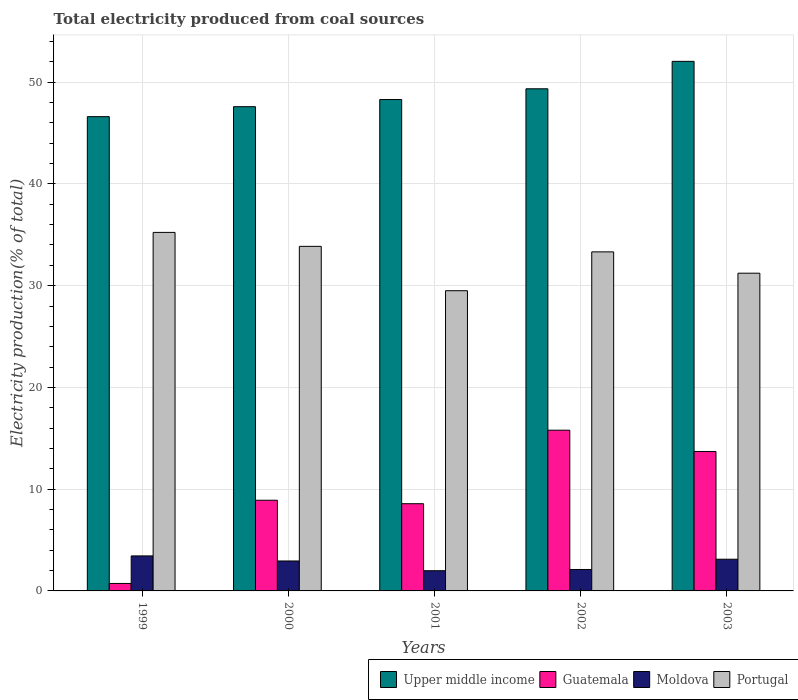How many groups of bars are there?
Your answer should be very brief. 5. Are the number of bars per tick equal to the number of legend labels?
Your answer should be very brief. Yes. Are the number of bars on each tick of the X-axis equal?
Your response must be concise. Yes. How many bars are there on the 3rd tick from the left?
Offer a terse response. 4. How many bars are there on the 3rd tick from the right?
Offer a very short reply. 4. What is the label of the 4th group of bars from the left?
Your response must be concise. 2002. In how many cases, is the number of bars for a given year not equal to the number of legend labels?
Provide a succinct answer. 0. What is the total electricity produced in Portugal in 2002?
Your answer should be compact. 33.32. Across all years, what is the maximum total electricity produced in Upper middle income?
Your answer should be compact. 52.05. Across all years, what is the minimum total electricity produced in Portugal?
Your answer should be very brief. 29.51. In which year was the total electricity produced in Portugal maximum?
Ensure brevity in your answer.  1999. What is the total total electricity produced in Moldova in the graph?
Make the answer very short. 13.59. What is the difference between the total electricity produced in Moldova in 2001 and that in 2002?
Offer a terse response. -0.12. What is the difference between the total electricity produced in Portugal in 2000 and the total electricity produced in Moldova in 1999?
Give a very brief answer. 30.42. What is the average total electricity produced in Portugal per year?
Your answer should be compact. 32.63. In the year 2000, what is the difference between the total electricity produced in Upper middle income and total electricity produced in Portugal?
Offer a very short reply. 13.73. In how many years, is the total electricity produced in Upper middle income greater than 14 %?
Your answer should be very brief. 5. What is the ratio of the total electricity produced in Guatemala in 2000 to that in 2001?
Make the answer very short. 1.04. What is the difference between the highest and the second highest total electricity produced in Moldova?
Provide a succinct answer. 0.33. What is the difference between the highest and the lowest total electricity produced in Guatemala?
Your answer should be compact. 15.06. Is the sum of the total electricity produced in Upper middle income in 2001 and 2003 greater than the maximum total electricity produced in Guatemala across all years?
Offer a very short reply. Yes. What does the 1st bar from the right in 1999 represents?
Provide a succinct answer. Portugal. Is it the case that in every year, the sum of the total electricity produced in Moldova and total electricity produced in Guatemala is greater than the total electricity produced in Portugal?
Your answer should be very brief. No. Are all the bars in the graph horizontal?
Offer a terse response. No. How many years are there in the graph?
Give a very brief answer. 5. How many legend labels are there?
Keep it short and to the point. 4. How are the legend labels stacked?
Keep it short and to the point. Horizontal. What is the title of the graph?
Give a very brief answer. Total electricity produced from coal sources. What is the label or title of the X-axis?
Your answer should be compact. Years. What is the Electricity production(% of total) in Upper middle income in 1999?
Provide a short and direct response. 46.61. What is the Electricity production(% of total) of Guatemala in 1999?
Provide a short and direct response. 0.73. What is the Electricity production(% of total) in Moldova in 1999?
Your answer should be compact. 3.44. What is the Electricity production(% of total) in Portugal in 1999?
Keep it short and to the point. 35.24. What is the Electricity production(% of total) in Upper middle income in 2000?
Make the answer very short. 47.59. What is the Electricity production(% of total) of Guatemala in 2000?
Your answer should be very brief. 8.91. What is the Electricity production(% of total) in Moldova in 2000?
Your response must be concise. 2.94. What is the Electricity production(% of total) of Portugal in 2000?
Provide a short and direct response. 33.87. What is the Electricity production(% of total) in Upper middle income in 2001?
Make the answer very short. 48.29. What is the Electricity production(% of total) of Guatemala in 2001?
Ensure brevity in your answer.  8.57. What is the Electricity production(% of total) in Moldova in 2001?
Ensure brevity in your answer.  1.99. What is the Electricity production(% of total) in Portugal in 2001?
Offer a very short reply. 29.51. What is the Electricity production(% of total) of Upper middle income in 2002?
Offer a very short reply. 49.35. What is the Electricity production(% of total) in Guatemala in 2002?
Your response must be concise. 15.8. What is the Electricity production(% of total) of Moldova in 2002?
Ensure brevity in your answer.  2.11. What is the Electricity production(% of total) of Portugal in 2002?
Your answer should be compact. 33.32. What is the Electricity production(% of total) in Upper middle income in 2003?
Offer a terse response. 52.05. What is the Electricity production(% of total) of Guatemala in 2003?
Keep it short and to the point. 13.71. What is the Electricity production(% of total) in Moldova in 2003?
Your answer should be compact. 3.12. What is the Electricity production(% of total) in Portugal in 2003?
Offer a very short reply. 31.23. Across all years, what is the maximum Electricity production(% of total) of Upper middle income?
Ensure brevity in your answer.  52.05. Across all years, what is the maximum Electricity production(% of total) of Guatemala?
Offer a terse response. 15.8. Across all years, what is the maximum Electricity production(% of total) in Moldova?
Keep it short and to the point. 3.44. Across all years, what is the maximum Electricity production(% of total) of Portugal?
Offer a very short reply. 35.24. Across all years, what is the minimum Electricity production(% of total) in Upper middle income?
Offer a very short reply. 46.61. Across all years, what is the minimum Electricity production(% of total) of Guatemala?
Give a very brief answer. 0.73. Across all years, what is the minimum Electricity production(% of total) in Moldova?
Offer a terse response. 1.99. Across all years, what is the minimum Electricity production(% of total) in Portugal?
Your answer should be very brief. 29.51. What is the total Electricity production(% of total) of Upper middle income in the graph?
Ensure brevity in your answer.  243.9. What is the total Electricity production(% of total) of Guatemala in the graph?
Your answer should be compact. 47.72. What is the total Electricity production(% of total) in Moldova in the graph?
Give a very brief answer. 13.59. What is the total Electricity production(% of total) in Portugal in the graph?
Your answer should be compact. 163.16. What is the difference between the Electricity production(% of total) in Upper middle income in 1999 and that in 2000?
Provide a succinct answer. -0.98. What is the difference between the Electricity production(% of total) of Guatemala in 1999 and that in 2000?
Make the answer very short. -8.18. What is the difference between the Electricity production(% of total) of Moldova in 1999 and that in 2000?
Provide a short and direct response. 0.5. What is the difference between the Electricity production(% of total) of Portugal in 1999 and that in 2000?
Make the answer very short. 1.37. What is the difference between the Electricity production(% of total) of Upper middle income in 1999 and that in 2001?
Make the answer very short. -1.68. What is the difference between the Electricity production(% of total) in Guatemala in 1999 and that in 2001?
Give a very brief answer. -7.84. What is the difference between the Electricity production(% of total) of Moldova in 1999 and that in 2001?
Offer a very short reply. 1.45. What is the difference between the Electricity production(% of total) in Portugal in 1999 and that in 2001?
Make the answer very short. 5.73. What is the difference between the Electricity production(% of total) of Upper middle income in 1999 and that in 2002?
Your answer should be very brief. -2.74. What is the difference between the Electricity production(% of total) in Guatemala in 1999 and that in 2002?
Offer a terse response. -15.06. What is the difference between the Electricity production(% of total) of Moldova in 1999 and that in 2002?
Keep it short and to the point. 1.33. What is the difference between the Electricity production(% of total) of Portugal in 1999 and that in 2002?
Offer a very short reply. 1.91. What is the difference between the Electricity production(% of total) of Upper middle income in 1999 and that in 2003?
Your response must be concise. -5.44. What is the difference between the Electricity production(% of total) in Guatemala in 1999 and that in 2003?
Make the answer very short. -12.97. What is the difference between the Electricity production(% of total) of Moldova in 1999 and that in 2003?
Provide a succinct answer. 0.33. What is the difference between the Electricity production(% of total) in Portugal in 1999 and that in 2003?
Your answer should be very brief. 4.01. What is the difference between the Electricity production(% of total) of Upper middle income in 2000 and that in 2001?
Keep it short and to the point. -0.7. What is the difference between the Electricity production(% of total) of Guatemala in 2000 and that in 2001?
Provide a succinct answer. 0.34. What is the difference between the Electricity production(% of total) of Portugal in 2000 and that in 2001?
Provide a succinct answer. 4.36. What is the difference between the Electricity production(% of total) in Upper middle income in 2000 and that in 2002?
Offer a very short reply. -1.76. What is the difference between the Electricity production(% of total) in Guatemala in 2000 and that in 2002?
Offer a terse response. -6.89. What is the difference between the Electricity production(% of total) in Moldova in 2000 and that in 2002?
Give a very brief answer. 0.84. What is the difference between the Electricity production(% of total) in Portugal in 2000 and that in 2002?
Ensure brevity in your answer.  0.54. What is the difference between the Electricity production(% of total) in Upper middle income in 2000 and that in 2003?
Provide a short and direct response. -4.45. What is the difference between the Electricity production(% of total) of Guatemala in 2000 and that in 2003?
Provide a succinct answer. -4.79. What is the difference between the Electricity production(% of total) in Moldova in 2000 and that in 2003?
Offer a very short reply. -0.17. What is the difference between the Electricity production(% of total) in Portugal in 2000 and that in 2003?
Your answer should be very brief. 2.64. What is the difference between the Electricity production(% of total) of Upper middle income in 2001 and that in 2002?
Provide a short and direct response. -1.06. What is the difference between the Electricity production(% of total) of Guatemala in 2001 and that in 2002?
Offer a terse response. -7.23. What is the difference between the Electricity production(% of total) of Moldova in 2001 and that in 2002?
Make the answer very short. -0.12. What is the difference between the Electricity production(% of total) of Portugal in 2001 and that in 2002?
Your answer should be compact. -3.82. What is the difference between the Electricity production(% of total) in Upper middle income in 2001 and that in 2003?
Give a very brief answer. -3.75. What is the difference between the Electricity production(% of total) in Guatemala in 2001 and that in 2003?
Offer a terse response. -5.13. What is the difference between the Electricity production(% of total) in Moldova in 2001 and that in 2003?
Your answer should be compact. -1.13. What is the difference between the Electricity production(% of total) in Portugal in 2001 and that in 2003?
Your response must be concise. -1.72. What is the difference between the Electricity production(% of total) of Upper middle income in 2002 and that in 2003?
Your response must be concise. -2.7. What is the difference between the Electricity production(% of total) of Guatemala in 2002 and that in 2003?
Offer a very short reply. 2.09. What is the difference between the Electricity production(% of total) of Moldova in 2002 and that in 2003?
Provide a short and direct response. -1.01. What is the difference between the Electricity production(% of total) in Portugal in 2002 and that in 2003?
Keep it short and to the point. 2.1. What is the difference between the Electricity production(% of total) in Upper middle income in 1999 and the Electricity production(% of total) in Guatemala in 2000?
Ensure brevity in your answer.  37.7. What is the difference between the Electricity production(% of total) of Upper middle income in 1999 and the Electricity production(% of total) of Moldova in 2000?
Provide a short and direct response. 43.67. What is the difference between the Electricity production(% of total) of Upper middle income in 1999 and the Electricity production(% of total) of Portugal in 2000?
Provide a succinct answer. 12.75. What is the difference between the Electricity production(% of total) in Guatemala in 1999 and the Electricity production(% of total) in Moldova in 2000?
Give a very brief answer. -2.21. What is the difference between the Electricity production(% of total) of Guatemala in 1999 and the Electricity production(% of total) of Portugal in 2000?
Your answer should be compact. -33.13. What is the difference between the Electricity production(% of total) in Moldova in 1999 and the Electricity production(% of total) in Portugal in 2000?
Your response must be concise. -30.42. What is the difference between the Electricity production(% of total) in Upper middle income in 1999 and the Electricity production(% of total) in Guatemala in 2001?
Keep it short and to the point. 38.04. What is the difference between the Electricity production(% of total) of Upper middle income in 1999 and the Electricity production(% of total) of Moldova in 2001?
Provide a succinct answer. 44.63. What is the difference between the Electricity production(% of total) in Upper middle income in 1999 and the Electricity production(% of total) in Portugal in 2001?
Provide a short and direct response. 17.11. What is the difference between the Electricity production(% of total) of Guatemala in 1999 and the Electricity production(% of total) of Moldova in 2001?
Offer a terse response. -1.25. What is the difference between the Electricity production(% of total) of Guatemala in 1999 and the Electricity production(% of total) of Portugal in 2001?
Your answer should be very brief. -28.77. What is the difference between the Electricity production(% of total) in Moldova in 1999 and the Electricity production(% of total) in Portugal in 2001?
Offer a very short reply. -26.06. What is the difference between the Electricity production(% of total) in Upper middle income in 1999 and the Electricity production(% of total) in Guatemala in 2002?
Your answer should be very brief. 30.81. What is the difference between the Electricity production(% of total) in Upper middle income in 1999 and the Electricity production(% of total) in Moldova in 2002?
Offer a terse response. 44.51. What is the difference between the Electricity production(% of total) of Upper middle income in 1999 and the Electricity production(% of total) of Portugal in 2002?
Keep it short and to the point. 13.29. What is the difference between the Electricity production(% of total) of Guatemala in 1999 and the Electricity production(% of total) of Moldova in 2002?
Your answer should be compact. -1.37. What is the difference between the Electricity production(% of total) in Guatemala in 1999 and the Electricity production(% of total) in Portugal in 2002?
Offer a terse response. -32.59. What is the difference between the Electricity production(% of total) in Moldova in 1999 and the Electricity production(% of total) in Portugal in 2002?
Keep it short and to the point. -29.88. What is the difference between the Electricity production(% of total) of Upper middle income in 1999 and the Electricity production(% of total) of Guatemala in 2003?
Give a very brief answer. 32.91. What is the difference between the Electricity production(% of total) of Upper middle income in 1999 and the Electricity production(% of total) of Moldova in 2003?
Provide a succinct answer. 43.5. What is the difference between the Electricity production(% of total) in Upper middle income in 1999 and the Electricity production(% of total) in Portugal in 2003?
Your answer should be very brief. 15.38. What is the difference between the Electricity production(% of total) in Guatemala in 1999 and the Electricity production(% of total) in Moldova in 2003?
Your answer should be compact. -2.38. What is the difference between the Electricity production(% of total) of Guatemala in 1999 and the Electricity production(% of total) of Portugal in 2003?
Ensure brevity in your answer.  -30.49. What is the difference between the Electricity production(% of total) in Moldova in 1999 and the Electricity production(% of total) in Portugal in 2003?
Your answer should be very brief. -27.79. What is the difference between the Electricity production(% of total) of Upper middle income in 2000 and the Electricity production(% of total) of Guatemala in 2001?
Your response must be concise. 39.02. What is the difference between the Electricity production(% of total) in Upper middle income in 2000 and the Electricity production(% of total) in Moldova in 2001?
Provide a short and direct response. 45.61. What is the difference between the Electricity production(% of total) in Upper middle income in 2000 and the Electricity production(% of total) in Portugal in 2001?
Your answer should be very brief. 18.09. What is the difference between the Electricity production(% of total) of Guatemala in 2000 and the Electricity production(% of total) of Moldova in 2001?
Give a very brief answer. 6.93. What is the difference between the Electricity production(% of total) in Guatemala in 2000 and the Electricity production(% of total) in Portugal in 2001?
Ensure brevity in your answer.  -20.59. What is the difference between the Electricity production(% of total) in Moldova in 2000 and the Electricity production(% of total) in Portugal in 2001?
Offer a very short reply. -26.56. What is the difference between the Electricity production(% of total) of Upper middle income in 2000 and the Electricity production(% of total) of Guatemala in 2002?
Give a very brief answer. 31.8. What is the difference between the Electricity production(% of total) of Upper middle income in 2000 and the Electricity production(% of total) of Moldova in 2002?
Provide a short and direct response. 45.49. What is the difference between the Electricity production(% of total) of Upper middle income in 2000 and the Electricity production(% of total) of Portugal in 2002?
Your answer should be compact. 14.27. What is the difference between the Electricity production(% of total) in Guatemala in 2000 and the Electricity production(% of total) in Moldova in 2002?
Provide a succinct answer. 6.81. What is the difference between the Electricity production(% of total) in Guatemala in 2000 and the Electricity production(% of total) in Portugal in 2002?
Your answer should be compact. -24.41. What is the difference between the Electricity production(% of total) of Moldova in 2000 and the Electricity production(% of total) of Portugal in 2002?
Provide a short and direct response. -30.38. What is the difference between the Electricity production(% of total) of Upper middle income in 2000 and the Electricity production(% of total) of Guatemala in 2003?
Your answer should be compact. 33.89. What is the difference between the Electricity production(% of total) of Upper middle income in 2000 and the Electricity production(% of total) of Moldova in 2003?
Offer a terse response. 44.48. What is the difference between the Electricity production(% of total) of Upper middle income in 2000 and the Electricity production(% of total) of Portugal in 2003?
Your answer should be very brief. 16.37. What is the difference between the Electricity production(% of total) in Guatemala in 2000 and the Electricity production(% of total) in Moldova in 2003?
Ensure brevity in your answer.  5.8. What is the difference between the Electricity production(% of total) of Guatemala in 2000 and the Electricity production(% of total) of Portugal in 2003?
Your answer should be very brief. -22.31. What is the difference between the Electricity production(% of total) of Moldova in 2000 and the Electricity production(% of total) of Portugal in 2003?
Provide a short and direct response. -28.28. What is the difference between the Electricity production(% of total) in Upper middle income in 2001 and the Electricity production(% of total) in Guatemala in 2002?
Provide a succinct answer. 32.5. What is the difference between the Electricity production(% of total) in Upper middle income in 2001 and the Electricity production(% of total) in Moldova in 2002?
Give a very brief answer. 46.19. What is the difference between the Electricity production(% of total) of Upper middle income in 2001 and the Electricity production(% of total) of Portugal in 2002?
Your answer should be compact. 14.97. What is the difference between the Electricity production(% of total) in Guatemala in 2001 and the Electricity production(% of total) in Moldova in 2002?
Make the answer very short. 6.46. What is the difference between the Electricity production(% of total) in Guatemala in 2001 and the Electricity production(% of total) in Portugal in 2002?
Offer a terse response. -24.75. What is the difference between the Electricity production(% of total) in Moldova in 2001 and the Electricity production(% of total) in Portugal in 2002?
Your answer should be compact. -31.34. What is the difference between the Electricity production(% of total) of Upper middle income in 2001 and the Electricity production(% of total) of Guatemala in 2003?
Your answer should be compact. 34.59. What is the difference between the Electricity production(% of total) in Upper middle income in 2001 and the Electricity production(% of total) in Moldova in 2003?
Your answer should be very brief. 45.18. What is the difference between the Electricity production(% of total) in Upper middle income in 2001 and the Electricity production(% of total) in Portugal in 2003?
Your response must be concise. 17.07. What is the difference between the Electricity production(% of total) in Guatemala in 2001 and the Electricity production(% of total) in Moldova in 2003?
Give a very brief answer. 5.46. What is the difference between the Electricity production(% of total) of Guatemala in 2001 and the Electricity production(% of total) of Portugal in 2003?
Provide a succinct answer. -22.66. What is the difference between the Electricity production(% of total) in Moldova in 2001 and the Electricity production(% of total) in Portugal in 2003?
Your answer should be very brief. -29.24. What is the difference between the Electricity production(% of total) in Upper middle income in 2002 and the Electricity production(% of total) in Guatemala in 2003?
Your answer should be compact. 35.65. What is the difference between the Electricity production(% of total) in Upper middle income in 2002 and the Electricity production(% of total) in Moldova in 2003?
Your response must be concise. 46.24. What is the difference between the Electricity production(% of total) in Upper middle income in 2002 and the Electricity production(% of total) in Portugal in 2003?
Give a very brief answer. 18.12. What is the difference between the Electricity production(% of total) of Guatemala in 2002 and the Electricity production(% of total) of Moldova in 2003?
Provide a short and direct response. 12.68. What is the difference between the Electricity production(% of total) of Guatemala in 2002 and the Electricity production(% of total) of Portugal in 2003?
Your answer should be compact. -15.43. What is the difference between the Electricity production(% of total) of Moldova in 2002 and the Electricity production(% of total) of Portugal in 2003?
Your response must be concise. -29.12. What is the average Electricity production(% of total) of Upper middle income per year?
Ensure brevity in your answer.  48.78. What is the average Electricity production(% of total) in Guatemala per year?
Make the answer very short. 9.54. What is the average Electricity production(% of total) in Moldova per year?
Ensure brevity in your answer.  2.72. What is the average Electricity production(% of total) in Portugal per year?
Your answer should be compact. 32.63. In the year 1999, what is the difference between the Electricity production(% of total) in Upper middle income and Electricity production(% of total) in Guatemala?
Give a very brief answer. 45.88. In the year 1999, what is the difference between the Electricity production(% of total) in Upper middle income and Electricity production(% of total) in Moldova?
Keep it short and to the point. 43.17. In the year 1999, what is the difference between the Electricity production(% of total) of Upper middle income and Electricity production(% of total) of Portugal?
Offer a very short reply. 11.38. In the year 1999, what is the difference between the Electricity production(% of total) in Guatemala and Electricity production(% of total) in Moldova?
Your answer should be very brief. -2.71. In the year 1999, what is the difference between the Electricity production(% of total) in Guatemala and Electricity production(% of total) in Portugal?
Keep it short and to the point. -34.5. In the year 1999, what is the difference between the Electricity production(% of total) in Moldova and Electricity production(% of total) in Portugal?
Make the answer very short. -31.8. In the year 2000, what is the difference between the Electricity production(% of total) in Upper middle income and Electricity production(% of total) in Guatemala?
Keep it short and to the point. 38.68. In the year 2000, what is the difference between the Electricity production(% of total) in Upper middle income and Electricity production(% of total) in Moldova?
Provide a short and direct response. 44.65. In the year 2000, what is the difference between the Electricity production(% of total) in Upper middle income and Electricity production(% of total) in Portugal?
Give a very brief answer. 13.73. In the year 2000, what is the difference between the Electricity production(% of total) of Guatemala and Electricity production(% of total) of Moldova?
Your answer should be very brief. 5.97. In the year 2000, what is the difference between the Electricity production(% of total) in Guatemala and Electricity production(% of total) in Portugal?
Your answer should be very brief. -24.95. In the year 2000, what is the difference between the Electricity production(% of total) in Moldova and Electricity production(% of total) in Portugal?
Your response must be concise. -30.92. In the year 2001, what is the difference between the Electricity production(% of total) in Upper middle income and Electricity production(% of total) in Guatemala?
Offer a terse response. 39.72. In the year 2001, what is the difference between the Electricity production(% of total) in Upper middle income and Electricity production(% of total) in Moldova?
Offer a terse response. 46.31. In the year 2001, what is the difference between the Electricity production(% of total) of Upper middle income and Electricity production(% of total) of Portugal?
Make the answer very short. 18.79. In the year 2001, what is the difference between the Electricity production(% of total) in Guatemala and Electricity production(% of total) in Moldova?
Your answer should be compact. 6.58. In the year 2001, what is the difference between the Electricity production(% of total) of Guatemala and Electricity production(% of total) of Portugal?
Provide a short and direct response. -20.93. In the year 2001, what is the difference between the Electricity production(% of total) in Moldova and Electricity production(% of total) in Portugal?
Provide a succinct answer. -27.52. In the year 2002, what is the difference between the Electricity production(% of total) of Upper middle income and Electricity production(% of total) of Guatemala?
Provide a succinct answer. 33.55. In the year 2002, what is the difference between the Electricity production(% of total) in Upper middle income and Electricity production(% of total) in Moldova?
Offer a terse response. 47.24. In the year 2002, what is the difference between the Electricity production(% of total) of Upper middle income and Electricity production(% of total) of Portugal?
Offer a terse response. 16.03. In the year 2002, what is the difference between the Electricity production(% of total) of Guatemala and Electricity production(% of total) of Moldova?
Make the answer very short. 13.69. In the year 2002, what is the difference between the Electricity production(% of total) in Guatemala and Electricity production(% of total) in Portugal?
Provide a short and direct response. -17.53. In the year 2002, what is the difference between the Electricity production(% of total) of Moldova and Electricity production(% of total) of Portugal?
Ensure brevity in your answer.  -31.22. In the year 2003, what is the difference between the Electricity production(% of total) in Upper middle income and Electricity production(% of total) in Guatemala?
Provide a short and direct response. 38.34. In the year 2003, what is the difference between the Electricity production(% of total) of Upper middle income and Electricity production(% of total) of Moldova?
Offer a very short reply. 48.93. In the year 2003, what is the difference between the Electricity production(% of total) in Upper middle income and Electricity production(% of total) in Portugal?
Provide a short and direct response. 20.82. In the year 2003, what is the difference between the Electricity production(% of total) of Guatemala and Electricity production(% of total) of Moldova?
Your response must be concise. 10.59. In the year 2003, what is the difference between the Electricity production(% of total) in Guatemala and Electricity production(% of total) in Portugal?
Your response must be concise. -17.52. In the year 2003, what is the difference between the Electricity production(% of total) in Moldova and Electricity production(% of total) in Portugal?
Offer a terse response. -28.11. What is the ratio of the Electricity production(% of total) in Upper middle income in 1999 to that in 2000?
Provide a succinct answer. 0.98. What is the ratio of the Electricity production(% of total) in Guatemala in 1999 to that in 2000?
Offer a terse response. 0.08. What is the ratio of the Electricity production(% of total) of Moldova in 1999 to that in 2000?
Your response must be concise. 1.17. What is the ratio of the Electricity production(% of total) of Portugal in 1999 to that in 2000?
Give a very brief answer. 1.04. What is the ratio of the Electricity production(% of total) in Upper middle income in 1999 to that in 2001?
Make the answer very short. 0.97. What is the ratio of the Electricity production(% of total) of Guatemala in 1999 to that in 2001?
Your answer should be compact. 0.09. What is the ratio of the Electricity production(% of total) of Moldova in 1999 to that in 2001?
Keep it short and to the point. 1.73. What is the ratio of the Electricity production(% of total) in Portugal in 1999 to that in 2001?
Ensure brevity in your answer.  1.19. What is the ratio of the Electricity production(% of total) in Upper middle income in 1999 to that in 2002?
Offer a terse response. 0.94. What is the ratio of the Electricity production(% of total) of Guatemala in 1999 to that in 2002?
Offer a terse response. 0.05. What is the ratio of the Electricity production(% of total) in Moldova in 1999 to that in 2002?
Keep it short and to the point. 1.63. What is the ratio of the Electricity production(% of total) of Portugal in 1999 to that in 2002?
Offer a very short reply. 1.06. What is the ratio of the Electricity production(% of total) in Upper middle income in 1999 to that in 2003?
Offer a terse response. 0.9. What is the ratio of the Electricity production(% of total) in Guatemala in 1999 to that in 2003?
Your answer should be very brief. 0.05. What is the ratio of the Electricity production(% of total) in Moldova in 1999 to that in 2003?
Provide a short and direct response. 1.1. What is the ratio of the Electricity production(% of total) in Portugal in 1999 to that in 2003?
Your response must be concise. 1.13. What is the ratio of the Electricity production(% of total) in Upper middle income in 2000 to that in 2001?
Offer a terse response. 0.99. What is the ratio of the Electricity production(% of total) of Guatemala in 2000 to that in 2001?
Keep it short and to the point. 1.04. What is the ratio of the Electricity production(% of total) in Moldova in 2000 to that in 2001?
Give a very brief answer. 1.48. What is the ratio of the Electricity production(% of total) of Portugal in 2000 to that in 2001?
Provide a short and direct response. 1.15. What is the ratio of the Electricity production(% of total) in Upper middle income in 2000 to that in 2002?
Your answer should be very brief. 0.96. What is the ratio of the Electricity production(% of total) of Guatemala in 2000 to that in 2002?
Ensure brevity in your answer.  0.56. What is the ratio of the Electricity production(% of total) of Moldova in 2000 to that in 2002?
Your answer should be compact. 1.4. What is the ratio of the Electricity production(% of total) in Portugal in 2000 to that in 2002?
Provide a short and direct response. 1.02. What is the ratio of the Electricity production(% of total) in Upper middle income in 2000 to that in 2003?
Make the answer very short. 0.91. What is the ratio of the Electricity production(% of total) in Guatemala in 2000 to that in 2003?
Provide a succinct answer. 0.65. What is the ratio of the Electricity production(% of total) in Moldova in 2000 to that in 2003?
Provide a short and direct response. 0.94. What is the ratio of the Electricity production(% of total) in Portugal in 2000 to that in 2003?
Make the answer very short. 1.08. What is the ratio of the Electricity production(% of total) of Upper middle income in 2001 to that in 2002?
Offer a terse response. 0.98. What is the ratio of the Electricity production(% of total) of Guatemala in 2001 to that in 2002?
Your answer should be compact. 0.54. What is the ratio of the Electricity production(% of total) in Moldova in 2001 to that in 2002?
Offer a terse response. 0.94. What is the ratio of the Electricity production(% of total) of Portugal in 2001 to that in 2002?
Give a very brief answer. 0.89. What is the ratio of the Electricity production(% of total) in Upper middle income in 2001 to that in 2003?
Offer a terse response. 0.93. What is the ratio of the Electricity production(% of total) in Guatemala in 2001 to that in 2003?
Provide a short and direct response. 0.63. What is the ratio of the Electricity production(% of total) of Moldova in 2001 to that in 2003?
Offer a very short reply. 0.64. What is the ratio of the Electricity production(% of total) in Portugal in 2001 to that in 2003?
Provide a succinct answer. 0.94. What is the ratio of the Electricity production(% of total) in Upper middle income in 2002 to that in 2003?
Provide a short and direct response. 0.95. What is the ratio of the Electricity production(% of total) in Guatemala in 2002 to that in 2003?
Your answer should be compact. 1.15. What is the ratio of the Electricity production(% of total) of Moldova in 2002 to that in 2003?
Offer a very short reply. 0.68. What is the ratio of the Electricity production(% of total) in Portugal in 2002 to that in 2003?
Your answer should be very brief. 1.07. What is the difference between the highest and the second highest Electricity production(% of total) of Upper middle income?
Ensure brevity in your answer.  2.7. What is the difference between the highest and the second highest Electricity production(% of total) of Guatemala?
Provide a succinct answer. 2.09. What is the difference between the highest and the second highest Electricity production(% of total) in Moldova?
Make the answer very short. 0.33. What is the difference between the highest and the second highest Electricity production(% of total) in Portugal?
Keep it short and to the point. 1.37. What is the difference between the highest and the lowest Electricity production(% of total) of Upper middle income?
Your response must be concise. 5.44. What is the difference between the highest and the lowest Electricity production(% of total) of Guatemala?
Keep it short and to the point. 15.06. What is the difference between the highest and the lowest Electricity production(% of total) of Moldova?
Provide a succinct answer. 1.45. What is the difference between the highest and the lowest Electricity production(% of total) of Portugal?
Give a very brief answer. 5.73. 